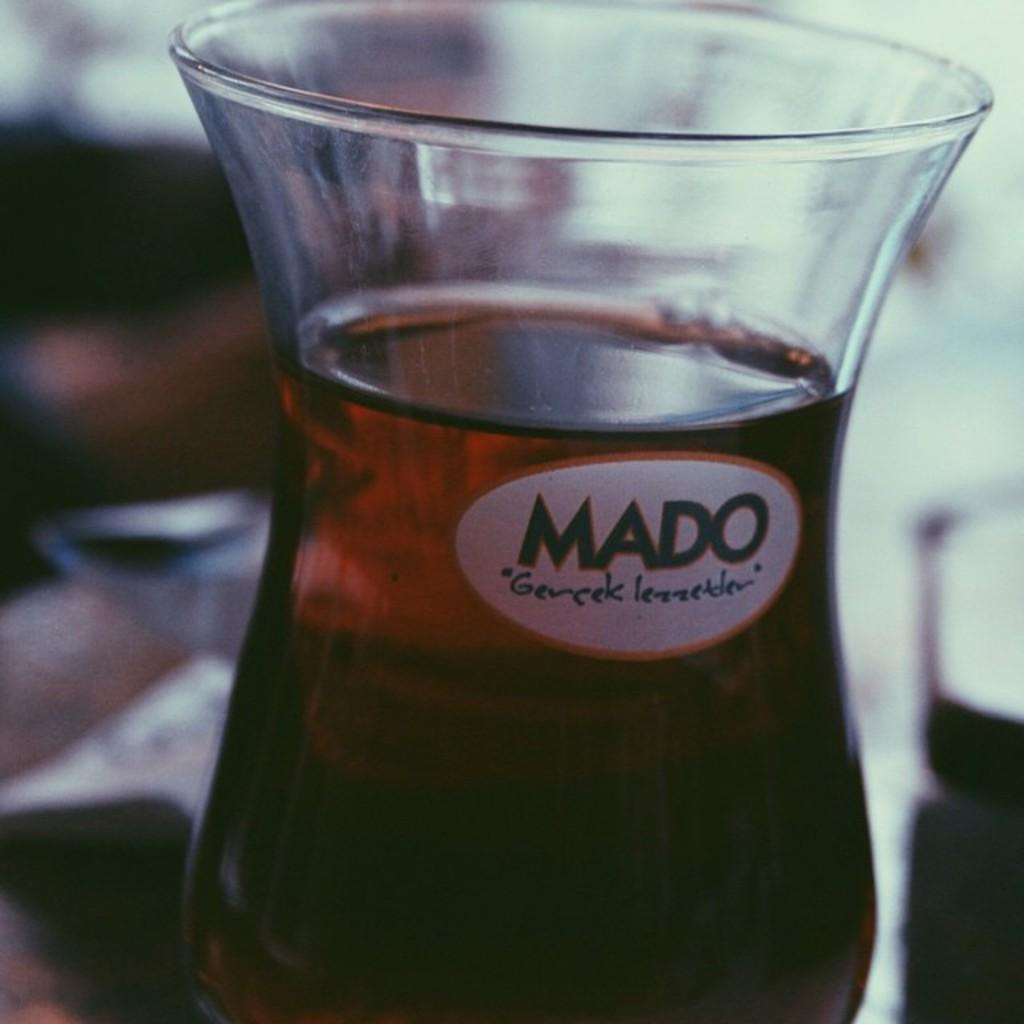<image>
Write a terse but informative summary of the picture. A dark drink inside a hurricane shaped glass that has a MADO logo. 